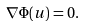<formula> <loc_0><loc_0><loc_500><loc_500>\nabla \Phi ( u ) = 0 .</formula> 